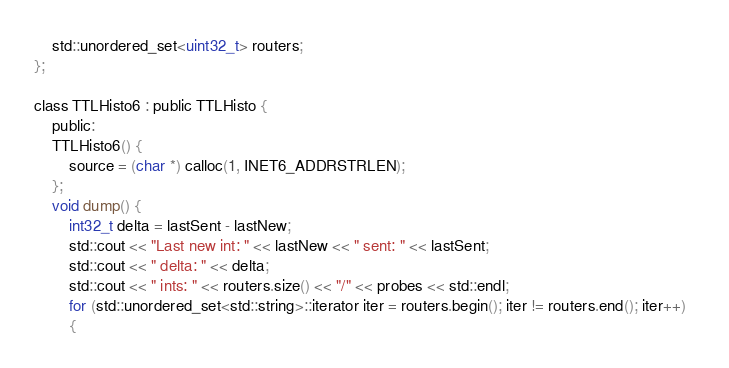Convert code to text. <code><loc_0><loc_0><loc_500><loc_500><_C_>	std::unordered_set<uint32_t> routers;
};

class TTLHisto6 : public TTLHisto {
    public:
    TTLHisto6() {
        source = (char *) calloc(1, INET6_ADDRSTRLEN);
    };
    void dump() {
        int32_t delta = lastSent - lastNew;
        std::cout << "Last new int: " << lastNew << " sent: " << lastSent;
        std::cout << " delta: " << delta;
        std::cout << " ints: " << routers.size() << "/" << probes << std::endl;
        for (std::unordered_set<std::string>::iterator iter = routers.begin(); iter != routers.end(); iter++)  
        {</code> 